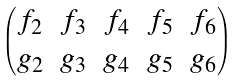Convert formula to latex. <formula><loc_0><loc_0><loc_500><loc_500>\begin{pmatrix} f _ { 2 } & f _ { 3 } & f _ { 4 } & f _ { 5 } & f _ { 6 } \\ g _ { 2 } & g _ { 3 } & g _ { 4 } & g _ { 5 } & g _ { 6 } \end{pmatrix}</formula> 